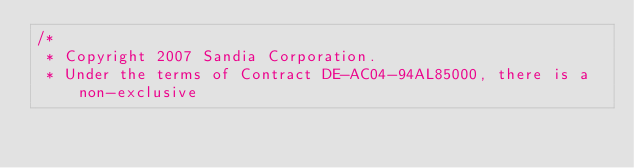Convert code to text. <code><loc_0><loc_0><loc_500><loc_500><_C++_>/*
 * Copyright 2007 Sandia Corporation.
 * Under the terms of Contract DE-AC04-94AL85000, there is a non-exclusive</code> 